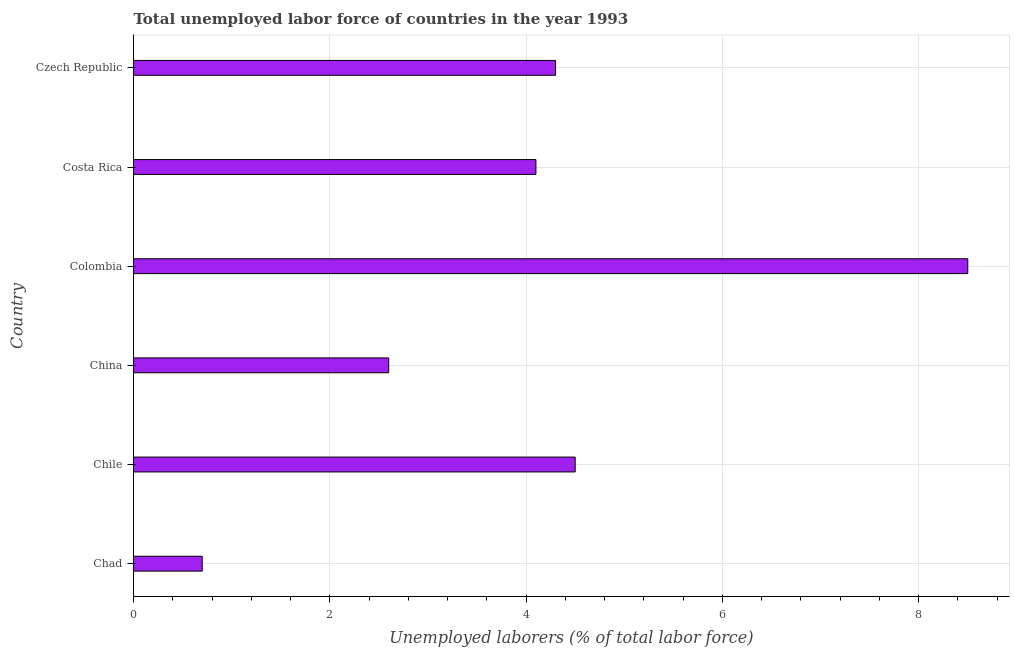Does the graph contain any zero values?
Your answer should be compact. No. Does the graph contain grids?
Make the answer very short. Yes. What is the title of the graph?
Offer a terse response. Total unemployed labor force of countries in the year 1993. What is the label or title of the X-axis?
Give a very brief answer. Unemployed laborers (% of total labor force). What is the total unemployed labour force in Chad?
Ensure brevity in your answer.  0.7. Across all countries, what is the maximum total unemployed labour force?
Give a very brief answer. 8.5. Across all countries, what is the minimum total unemployed labour force?
Ensure brevity in your answer.  0.7. In which country was the total unemployed labour force minimum?
Ensure brevity in your answer.  Chad. What is the sum of the total unemployed labour force?
Your response must be concise. 24.7. What is the difference between the total unemployed labour force in Chile and China?
Your response must be concise. 1.9. What is the average total unemployed labour force per country?
Provide a short and direct response. 4.12. What is the median total unemployed labour force?
Provide a succinct answer. 4.2. What is the ratio of the total unemployed labour force in Chile to that in China?
Offer a terse response. 1.73. Is the difference between the total unemployed labour force in Colombia and Czech Republic greater than the difference between any two countries?
Keep it short and to the point. No. How many bars are there?
Offer a terse response. 6. Are all the bars in the graph horizontal?
Make the answer very short. Yes. How many countries are there in the graph?
Your answer should be compact. 6. What is the difference between two consecutive major ticks on the X-axis?
Keep it short and to the point. 2. What is the Unemployed laborers (% of total labor force) in Chad?
Your response must be concise. 0.7. What is the Unemployed laborers (% of total labor force) of Chile?
Offer a terse response. 4.5. What is the Unemployed laborers (% of total labor force) of China?
Your response must be concise. 2.6. What is the Unemployed laborers (% of total labor force) in Colombia?
Offer a terse response. 8.5. What is the Unemployed laborers (% of total labor force) of Costa Rica?
Provide a succinct answer. 4.1. What is the Unemployed laborers (% of total labor force) in Czech Republic?
Make the answer very short. 4.3. What is the difference between the Unemployed laborers (% of total labor force) in Chad and Chile?
Ensure brevity in your answer.  -3.8. What is the difference between the Unemployed laborers (% of total labor force) in Chad and China?
Your answer should be compact. -1.9. What is the difference between the Unemployed laborers (% of total labor force) in Chad and Costa Rica?
Your answer should be very brief. -3.4. What is the difference between the Unemployed laborers (% of total labor force) in Chad and Czech Republic?
Your answer should be compact. -3.6. What is the difference between the Unemployed laborers (% of total labor force) in Chile and China?
Your answer should be compact. 1.9. What is the difference between the Unemployed laborers (% of total labor force) in Chile and Colombia?
Offer a very short reply. -4. What is the ratio of the Unemployed laborers (% of total labor force) in Chad to that in Chile?
Make the answer very short. 0.16. What is the ratio of the Unemployed laborers (% of total labor force) in Chad to that in China?
Keep it short and to the point. 0.27. What is the ratio of the Unemployed laborers (% of total labor force) in Chad to that in Colombia?
Provide a succinct answer. 0.08. What is the ratio of the Unemployed laborers (% of total labor force) in Chad to that in Costa Rica?
Ensure brevity in your answer.  0.17. What is the ratio of the Unemployed laborers (% of total labor force) in Chad to that in Czech Republic?
Ensure brevity in your answer.  0.16. What is the ratio of the Unemployed laborers (% of total labor force) in Chile to that in China?
Ensure brevity in your answer.  1.73. What is the ratio of the Unemployed laborers (% of total labor force) in Chile to that in Colombia?
Your response must be concise. 0.53. What is the ratio of the Unemployed laborers (% of total labor force) in Chile to that in Costa Rica?
Give a very brief answer. 1.1. What is the ratio of the Unemployed laborers (% of total labor force) in Chile to that in Czech Republic?
Provide a succinct answer. 1.05. What is the ratio of the Unemployed laborers (% of total labor force) in China to that in Colombia?
Offer a terse response. 0.31. What is the ratio of the Unemployed laborers (% of total labor force) in China to that in Costa Rica?
Offer a very short reply. 0.63. What is the ratio of the Unemployed laborers (% of total labor force) in China to that in Czech Republic?
Your response must be concise. 0.6. What is the ratio of the Unemployed laborers (% of total labor force) in Colombia to that in Costa Rica?
Offer a terse response. 2.07. What is the ratio of the Unemployed laborers (% of total labor force) in Colombia to that in Czech Republic?
Your answer should be very brief. 1.98. What is the ratio of the Unemployed laborers (% of total labor force) in Costa Rica to that in Czech Republic?
Your answer should be compact. 0.95. 